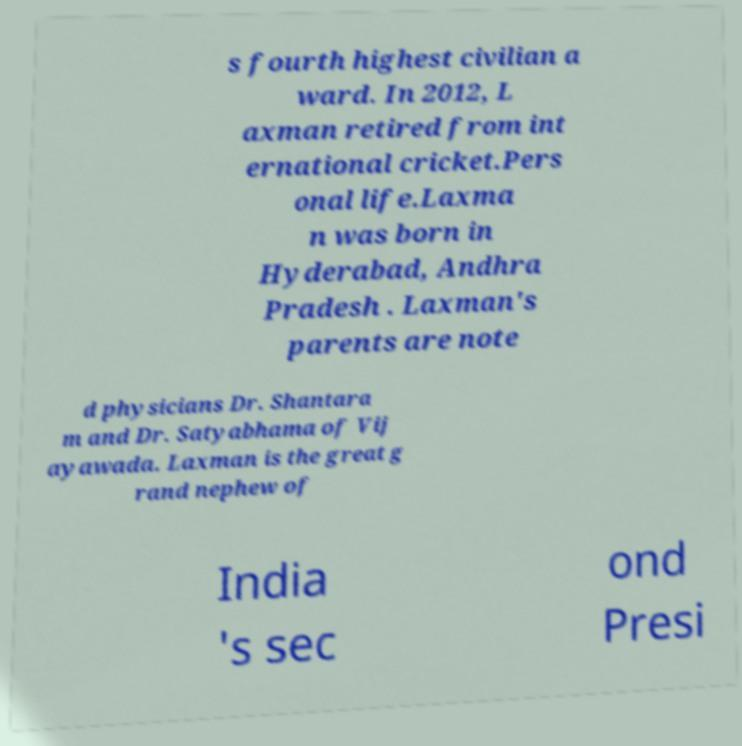Could you extract and type out the text from this image? s fourth highest civilian a ward. In 2012, L axman retired from int ernational cricket.Pers onal life.Laxma n was born in Hyderabad, Andhra Pradesh . Laxman's parents are note d physicians Dr. Shantara m and Dr. Satyabhama of Vij ayawada. Laxman is the great g rand nephew of India 's sec ond Presi 